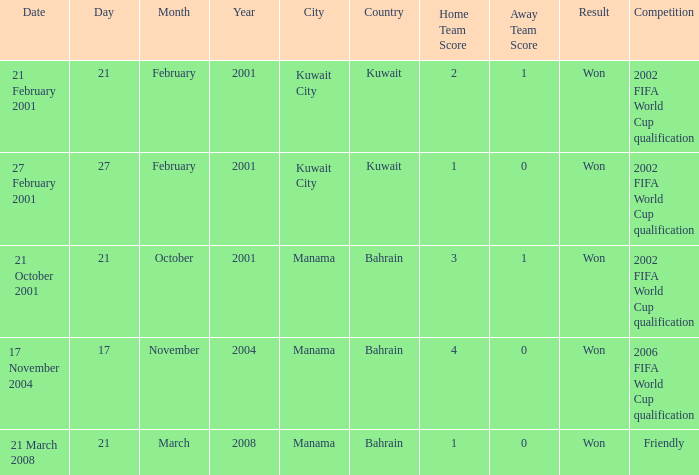What was the final score of the Friendly Competition in Manama, Bahrain? 1–0. 